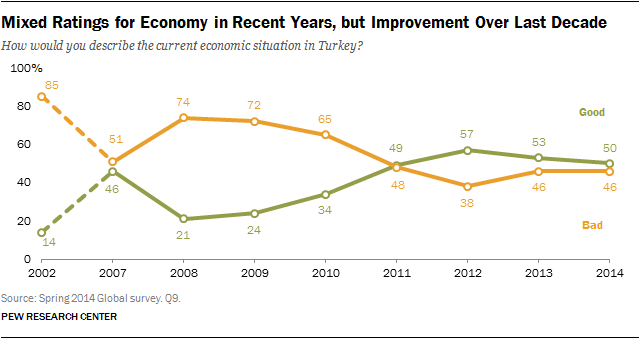Indicate a few pertinent items in this graphic. The Green bar represents good, according to the context provided. The least favorable economic situation in Turkey was 14%. 